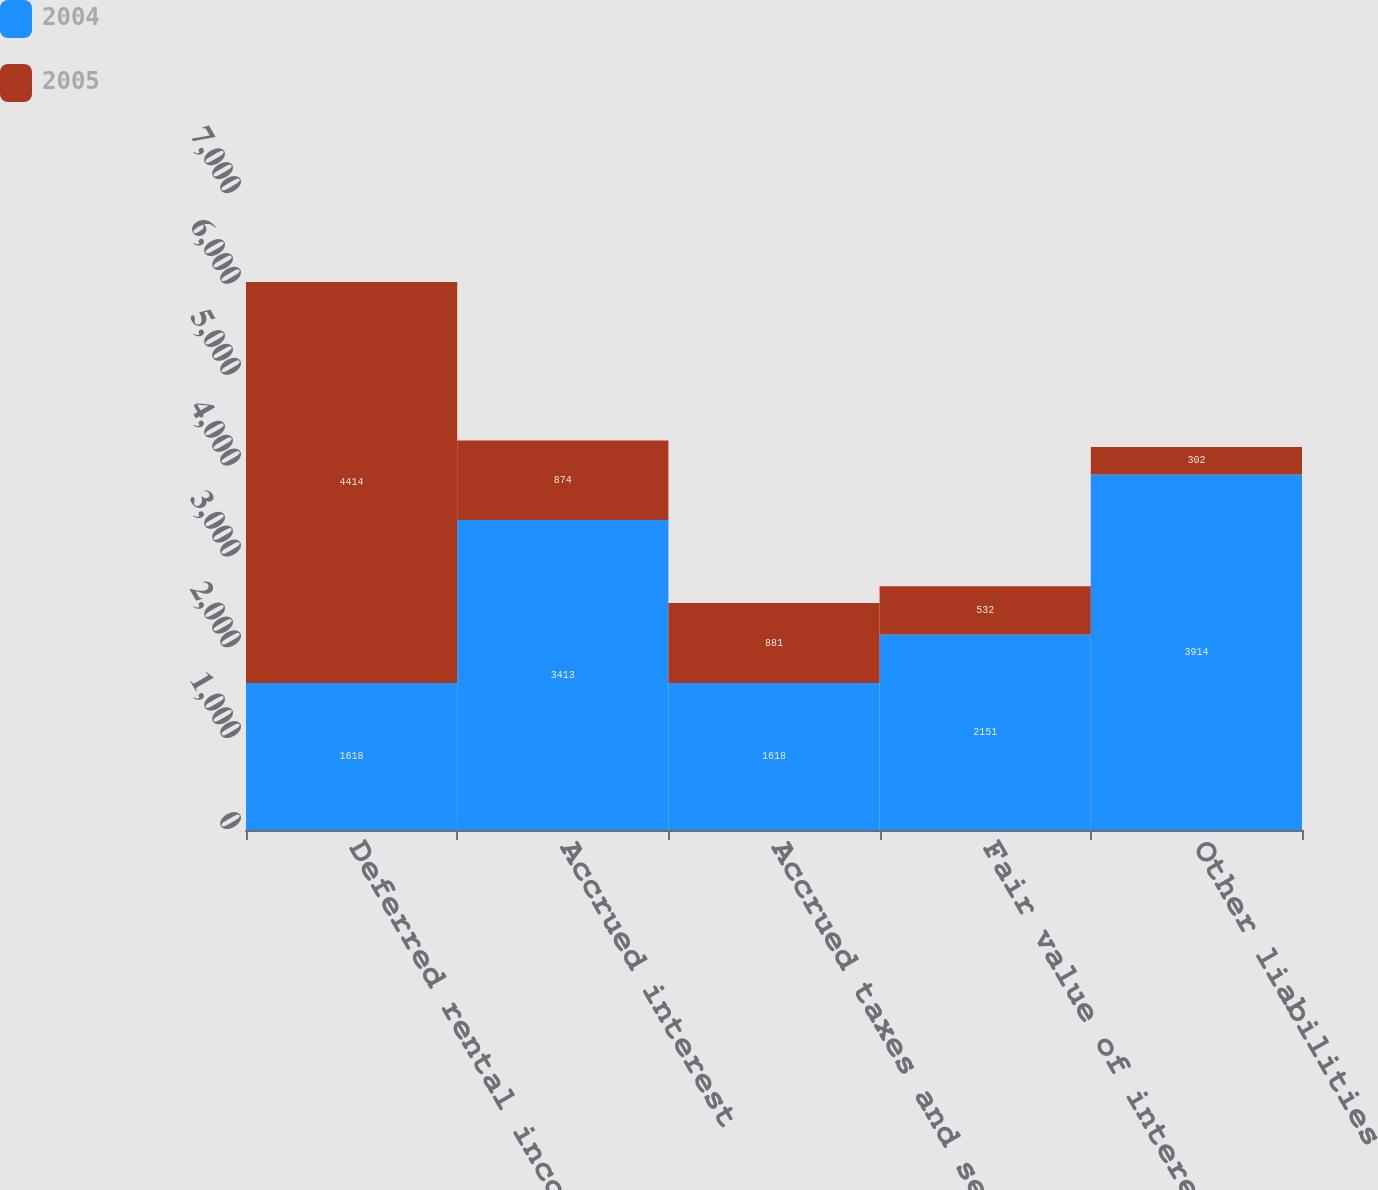Convert chart. <chart><loc_0><loc_0><loc_500><loc_500><stacked_bar_chart><ecel><fcel>Deferred rental income<fcel>Accrued interest<fcel>Accrued taxes and security<fcel>Fair value of interest rate<fcel>Other liabilities<nl><fcel>2004<fcel>1618<fcel>3413<fcel>1618<fcel>2151<fcel>3914<nl><fcel>2005<fcel>4414<fcel>874<fcel>881<fcel>532<fcel>302<nl></chart> 